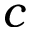<formula> <loc_0><loc_0><loc_500><loc_500>c</formula> 